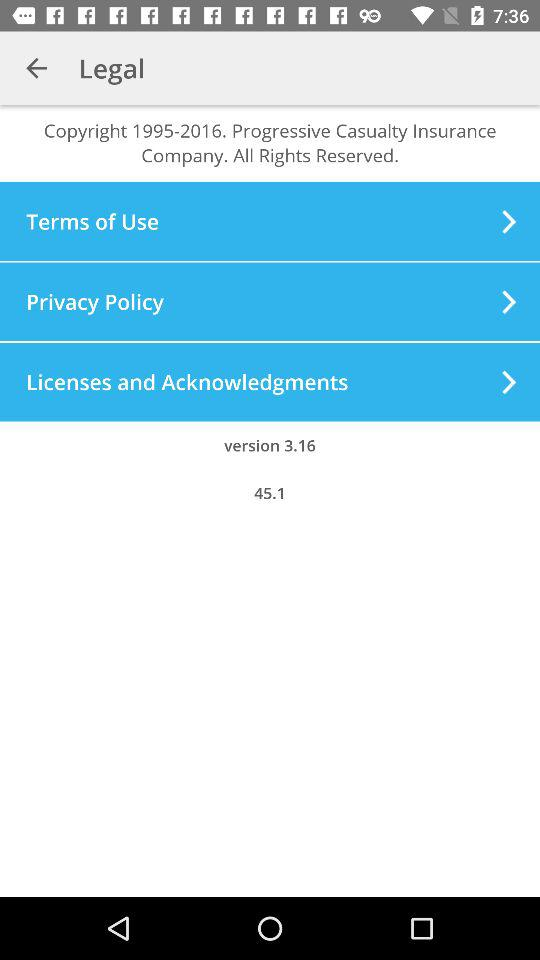What is the version? The version is 3.16. 